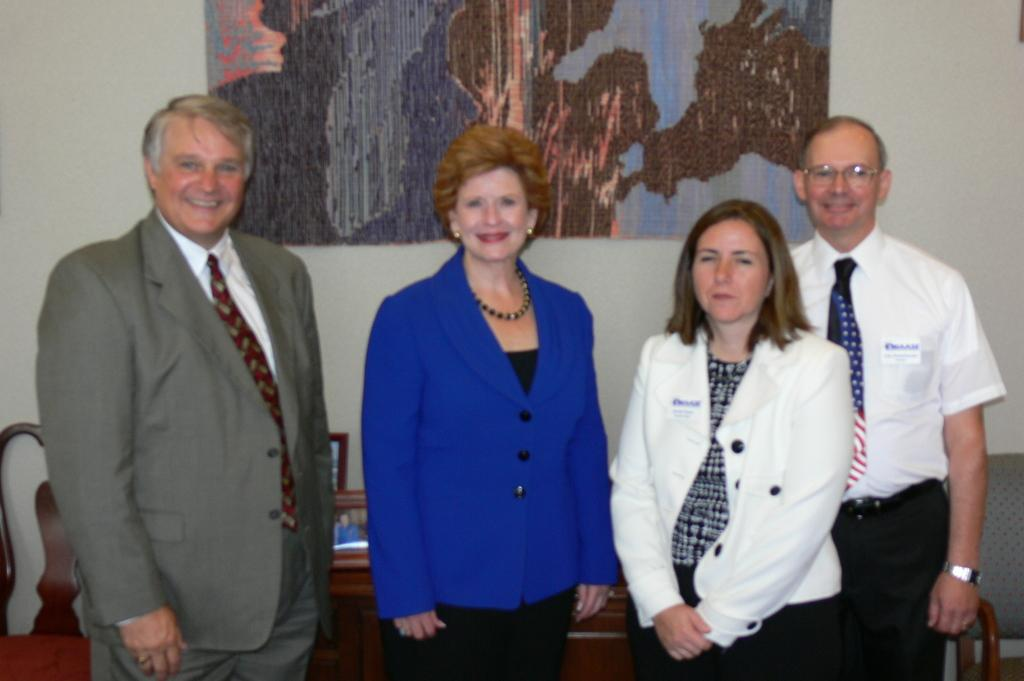How many people are in the image? There are four people in the image. What are the people on the left wearing? The two people on the left are wearing suits. What are the people on the right wearing? The two people on the right are wearing white dresses. What type of furniture can be seen in the image? There is a table and a chair in the image. How many eyes can be seen on the people in the image? The question about eyes cannot be answered definitively from the provided facts, as the number of eyes is not mentioned. 